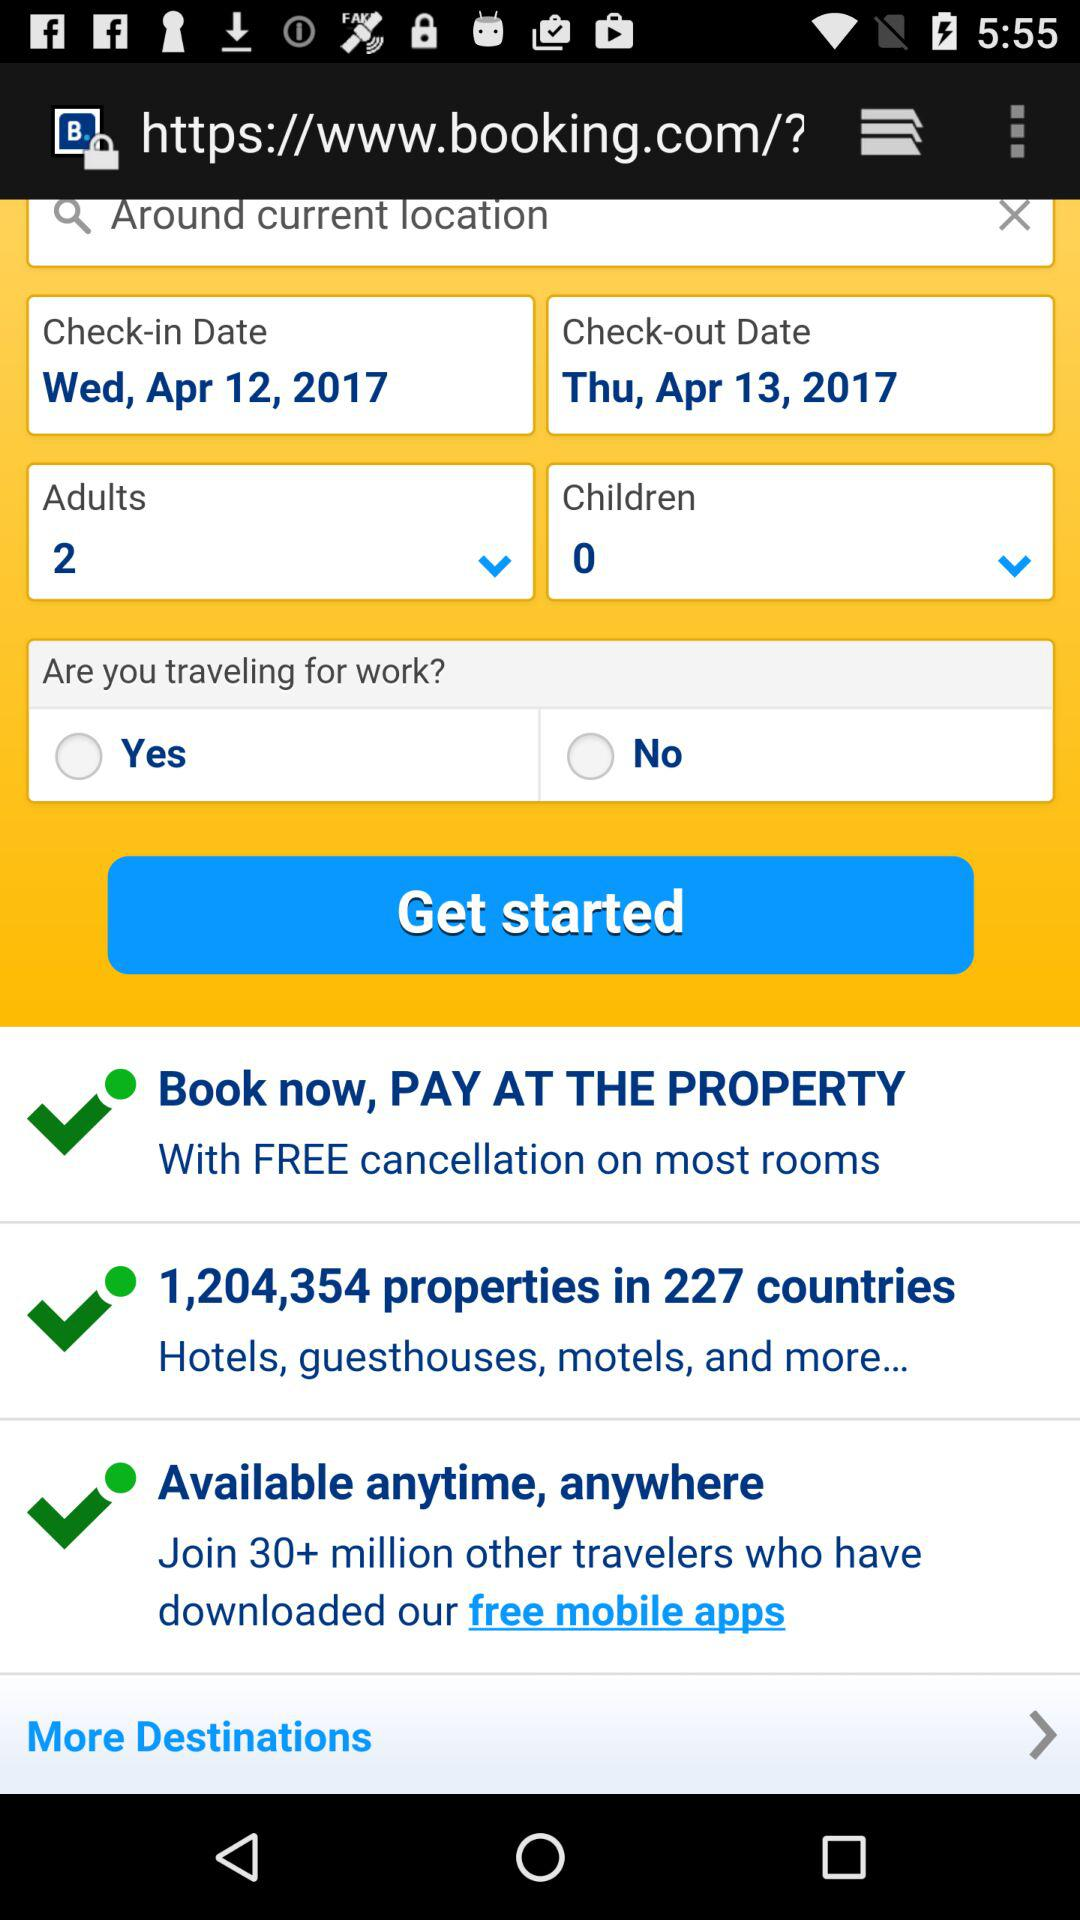How many properties are available in 227 countries? There are 1,204,354 properties available in 227 countries. 